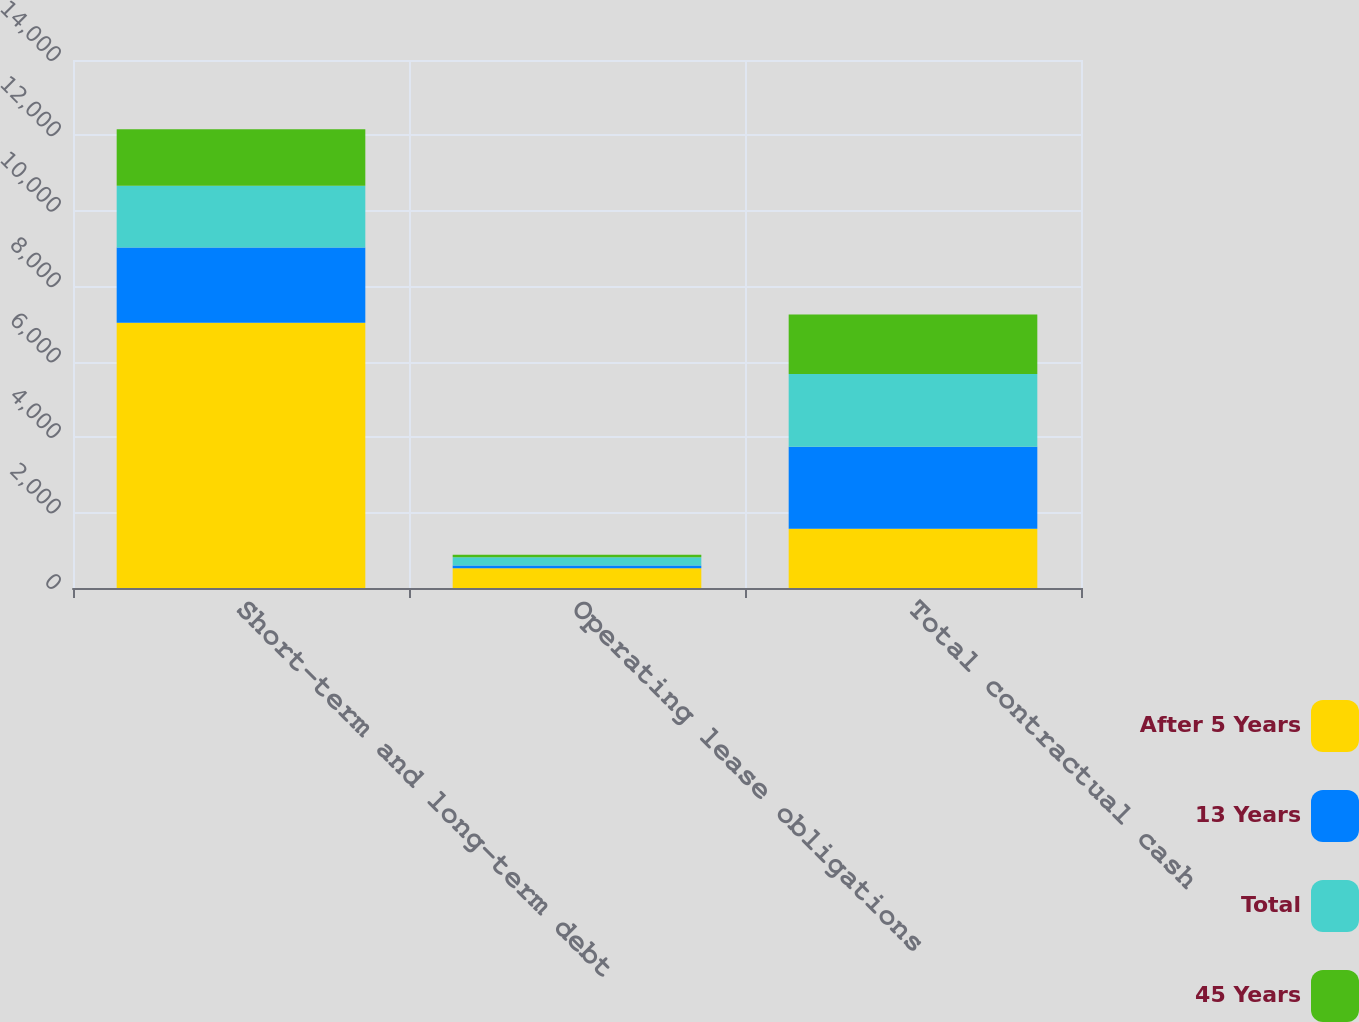Convert chart. <chart><loc_0><loc_0><loc_500><loc_500><stacked_bar_chart><ecel><fcel>Short-term and long-term debt<fcel>Operating lease obligations<fcel>Total contractual cash<nl><fcel>After 5 Years<fcel>7036<fcel>521<fcel>1574<nl><fcel>13 Years<fcel>1993<fcel>78<fcel>2172<nl><fcel>Total<fcel>1637<fcel>218<fcel>1931<nl><fcel>45 Years<fcel>1500<fcel>63<fcel>1574<nl></chart> 